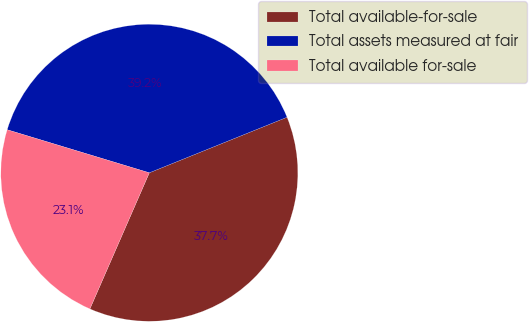Convert chart to OTSL. <chart><loc_0><loc_0><loc_500><loc_500><pie_chart><fcel>Total available-for-sale<fcel>Total assets measured at fair<fcel>Total available for-sale<nl><fcel>37.65%<fcel>39.21%<fcel>23.13%<nl></chart> 